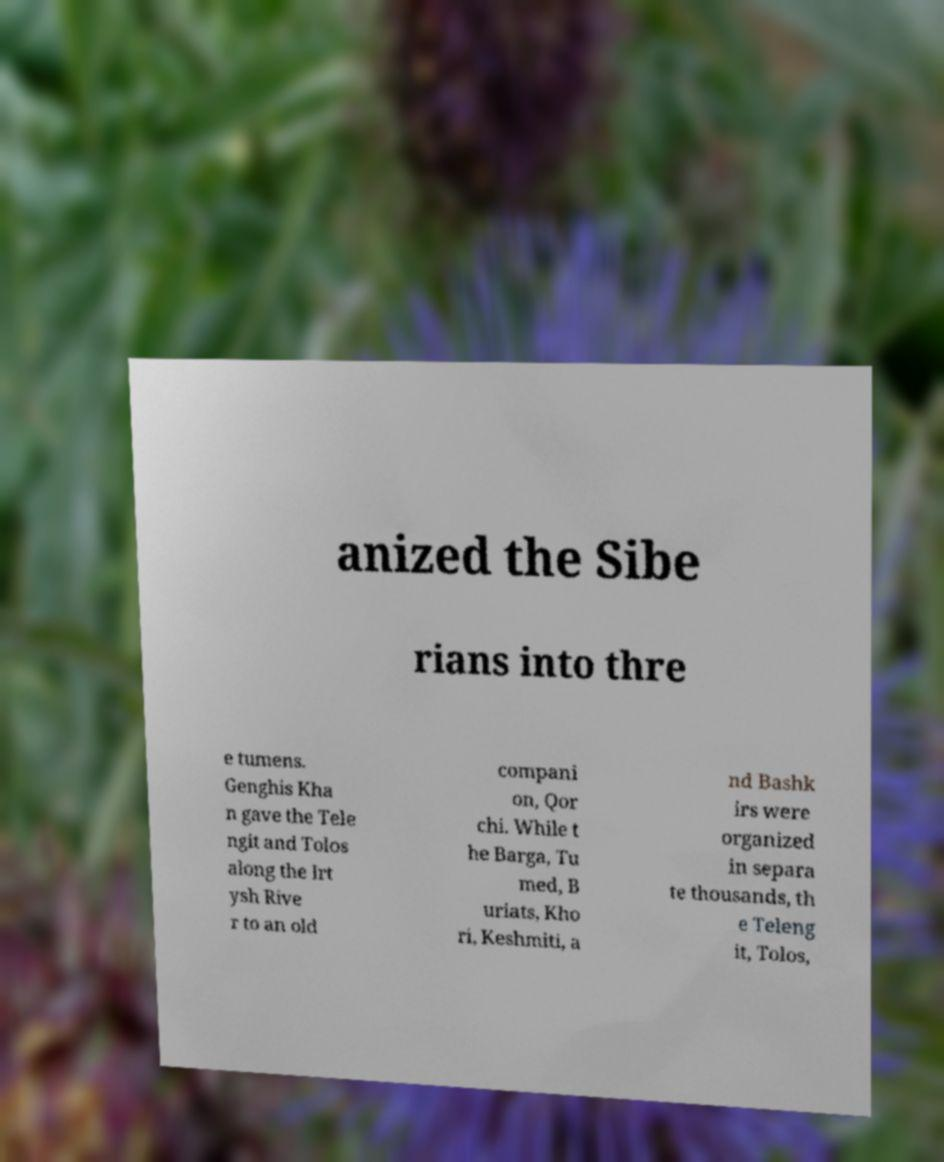Please read and relay the text visible in this image. What does it say? anized the Sibe rians into thre e tumens. Genghis Kha n gave the Tele ngit and Tolos along the Irt ysh Rive r to an old compani on, Qor chi. While t he Barga, Tu med, B uriats, Kho ri, Keshmiti, a nd Bashk irs were organized in separa te thousands, th e Teleng it, Tolos, 